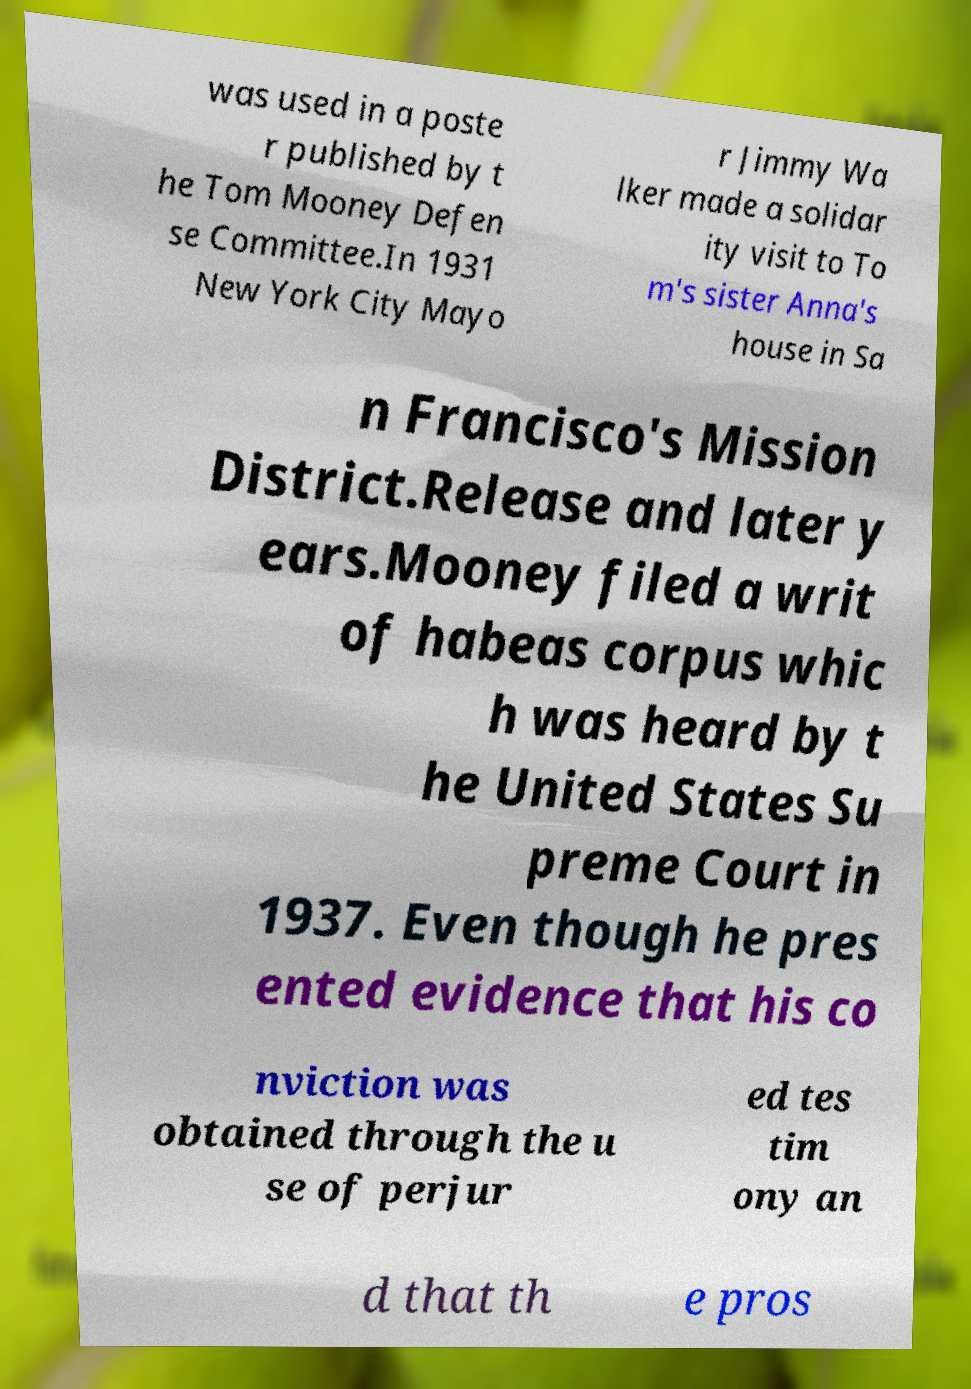There's text embedded in this image that I need extracted. Can you transcribe it verbatim? was used in a poste r published by t he Tom Mooney Defen se Committee.In 1931 New York City Mayo r Jimmy Wa lker made a solidar ity visit to To m's sister Anna's house in Sa n Francisco's Mission District.Release and later y ears.Mooney filed a writ of habeas corpus whic h was heard by t he United States Su preme Court in 1937. Even though he pres ented evidence that his co nviction was obtained through the u se of perjur ed tes tim ony an d that th e pros 